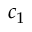Convert formula to latex. <formula><loc_0><loc_0><loc_500><loc_500>c _ { 1 }</formula> 